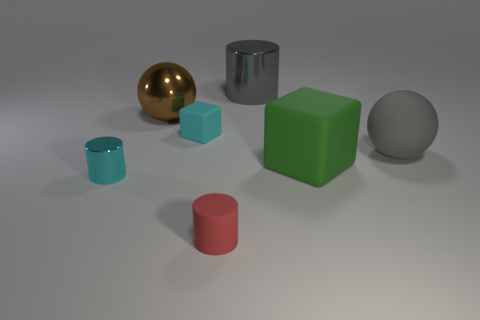Are there more small brown matte spheres than large brown shiny things?
Provide a short and direct response. No. Are the cyan cylinder and the green block made of the same material?
Make the answer very short. No. How many metallic things are big gray cylinders or small blocks?
Make the answer very short. 1. There is a metallic cylinder that is the same size as the metal ball; what color is it?
Keep it short and to the point. Gray. How many other large rubber things have the same shape as the brown thing?
Offer a very short reply. 1. How many cylinders are small cyan rubber objects or large gray metal things?
Provide a succinct answer. 1. There is a rubber thing in front of the tiny cyan metallic object; does it have the same shape as the tiny thing that is behind the green matte block?
Your answer should be very brief. No. What material is the big green block?
Your response must be concise. Rubber. There is a rubber thing that is the same color as the tiny metal object; what is its shape?
Keep it short and to the point. Cube. How many green rubber objects are the same size as the gray matte object?
Your answer should be compact. 1. 